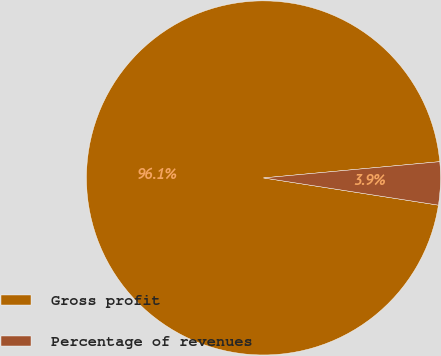<chart> <loc_0><loc_0><loc_500><loc_500><pie_chart><fcel>Gross profit<fcel>Percentage of revenues<nl><fcel>96.08%<fcel>3.92%<nl></chart> 